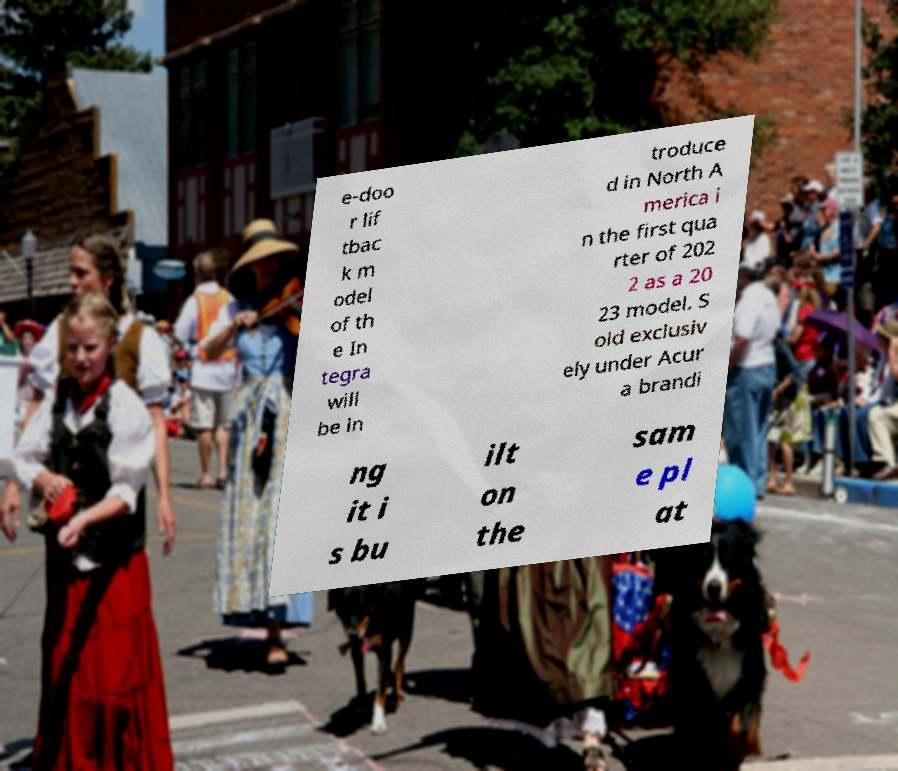Could you assist in decoding the text presented in this image and type it out clearly? e-doo r lif tbac k m odel of th e In tegra will be in troduce d in North A merica i n the first qua rter of 202 2 as a 20 23 model. S old exclusiv ely under Acur a brandi ng it i s bu ilt on the sam e pl at 